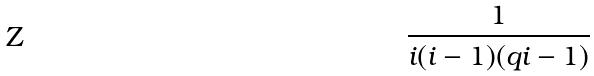Convert formula to latex. <formula><loc_0><loc_0><loc_500><loc_500>\frac { 1 } { i ( i - 1 ) ( q i - 1 ) }</formula> 